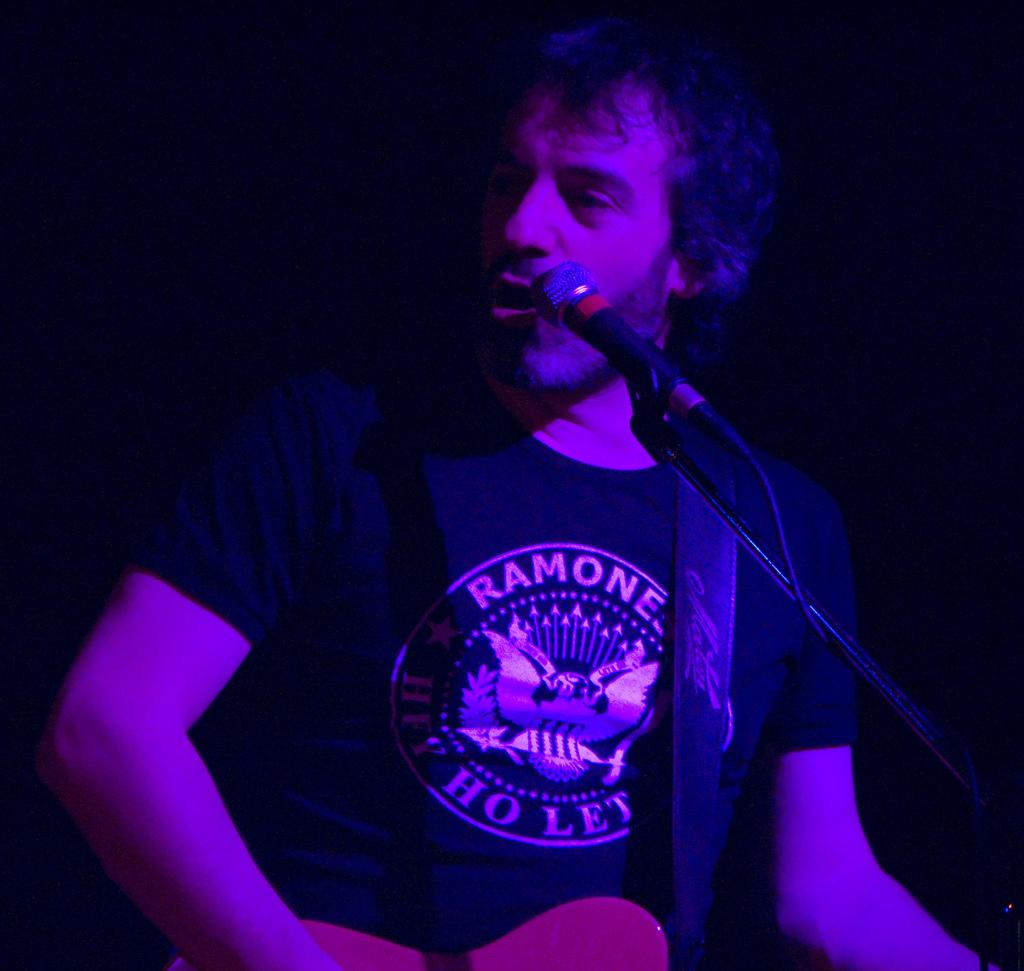Who is the main subject in the image? There is a man in the image. What is the man wearing? The man is wearing a t-shirt. What object is the man holding? The man is holding a guitar. What is the purpose of the microphone in front of the man? The microphone is likely used for amplifying the man's voice while playing the guitar. How would you describe the background of the image? The background of the image is dark. Can you tell me how many volcanoes are visible in the image? There are no volcanoes present in the image. What type of notebook is the man using to write down his song lyrics? There is no notebook present in the image, and the man is not shown writing anything. 